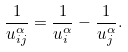Convert formula to latex. <formula><loc_0><loc_0><loc_500><loc_500>\frac { 1 } { u _ { i j } ^ { \alpha } } = \frac { 1 } { u _ { i } ^ { \alpha } } - \frac { 1 } { u _ { j } ^ { \alpha } } .</formula> 